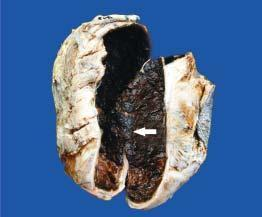does the wall of the stomach in the region of pyloric canal show thick wall coated internally by brownish, tan and necrotic material which is organised blood clot arrow?
Answer the question using a single word or phrase. No 